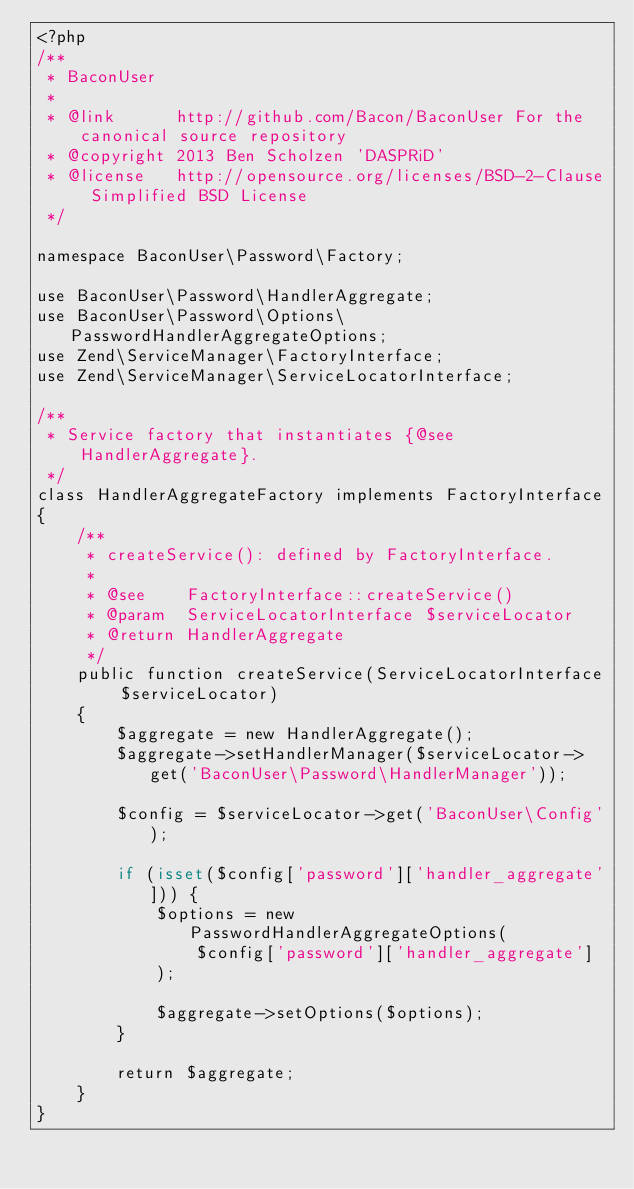Convert code to text. <code><loc_0><loc_0><loc_500><loc_500><_PHP_><?php
/**
 * BaconUser
 *
 * @link      http://github.com/Bacon/BaconUser For the canonical source repository
 * @copyright 2013 Ben Scholzen 'DASPRiD'
 * @license   http://opensource.org/licenses/BSD-2-Clause Simplified BSD License
 */

namespace BaconUser\Password\Factory;

use BaconUser\Password\HandlerAggregate;
use BaconUser\Password\Options\PasswordHandlerAggregateOptions;
use Zend\ServiceManager\FactoryInterface;
use Zend\ServiceManager\ServiceLocatorInterface;

/**
 * Service factory that instantiates {@see HandlerAggregate}.
 */
class HandlerAggregateFactory implements FactoryInterface
{
    /**
     * createService(): defined by FactoryInterface.
     *
     * @see    FactoryInterface::createService()
     * @param  ServiceLocatorInterface $serviceLocator
     * @return HandlerAggregate
     */
    public function createService(ServiceLocatorInterface $serviceLocator)
    {
        $aggregate = new HandlerAggregate();
        $aggregate->setHandlerManager($serviceLocator->get('BaconUser\Password\HandlerManager'));

        $config = $serviceLocator->get('BaconUser\Config');

        if (isset($config['password']['handler_aggregate'])) {
            $options = new PasswordHandlerAggregateOptions(
                $config['password']['handler_aggregate']
            );

            $aggregate->setOptions($options);
        }

        return $aggregate;
    }
}
</code> 